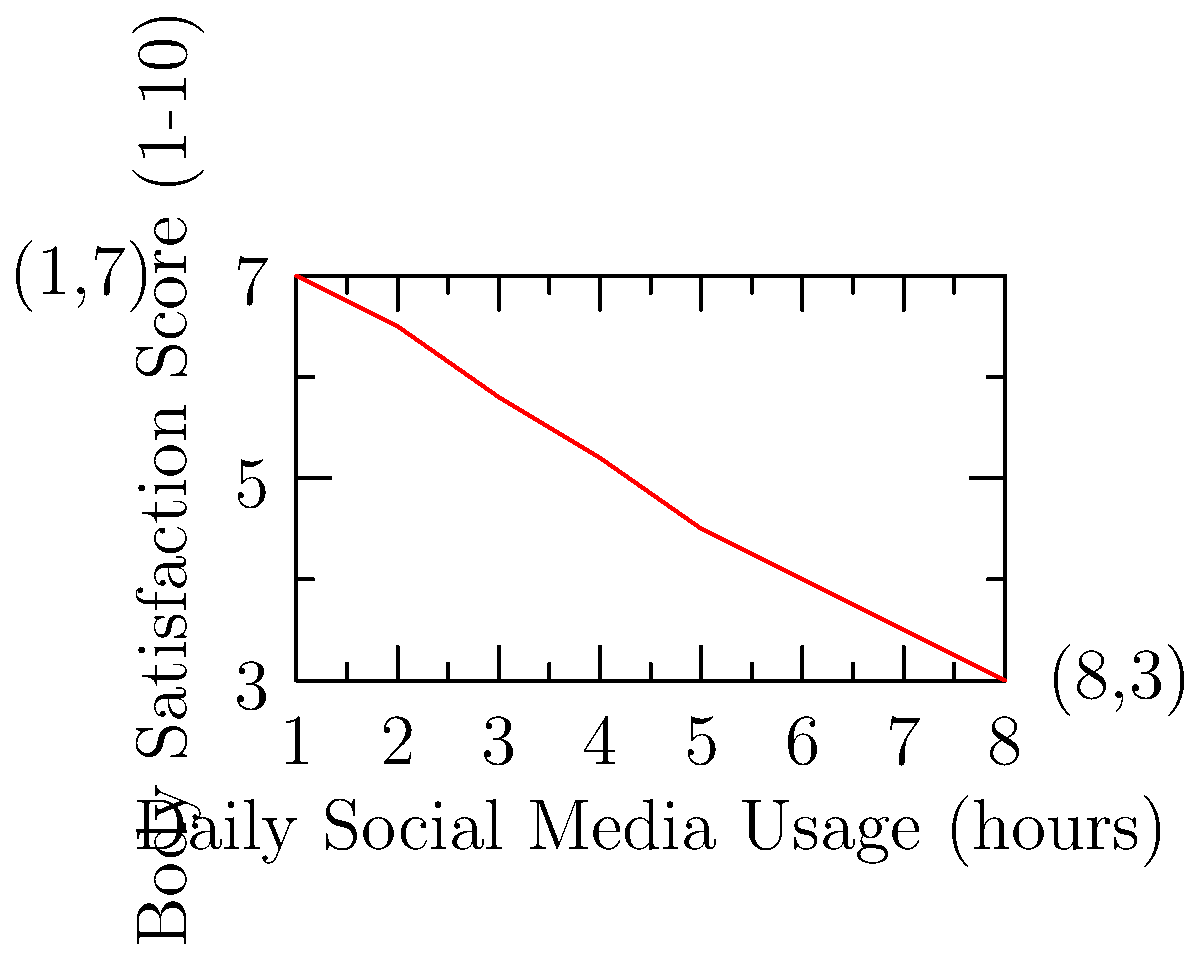Based on the scatter plot showing the relationship between daily social media usage and body satisfaction scores, what can be inferred about the correlation between these two variables? How might this information be relevant to your work as a journalist covering the influence of social media on body image? 1. Observe the overall trend: The scatter plot shows a clear downward trend from left to right.

2. Identify the correlation: As daily social media usage increases, body satisfaction scores decrease, indicating a negative correlation.

3. Assess the strength of the correlation: The points form a relatively straight line, suggesting a strong negative correlation.

4. Quantify the relationship: The body satisfaction score decreases by approximately 0.5-0.7 points for each additional hour of social media use.

5. Consider the extremes: At 1 hour of daily usage, the body satisfaction score is 7; at 8 hours, it drops to 3.

6. Journalistic relevance: This data supports the narrative that increased social media exposure may negatively impact body image and self-esteem. It provides quantitative evidence for articles on the potential harmful effects of excessive social media use on body satisfaction.

7. Research implications: This correlation could be used as a starting point for more in-depth studies on the causal relationship between social media use and body image issues.

8. Public health perspective: The data suggests that limiting social media use might be beneficial for maintaining higher body satisfaction, which could be an important message for readers.
Answer: Strong negative correlation between social media usage and body satisfaction, supporting the hypothesis that increased social media exposure may negatively impact body image. 